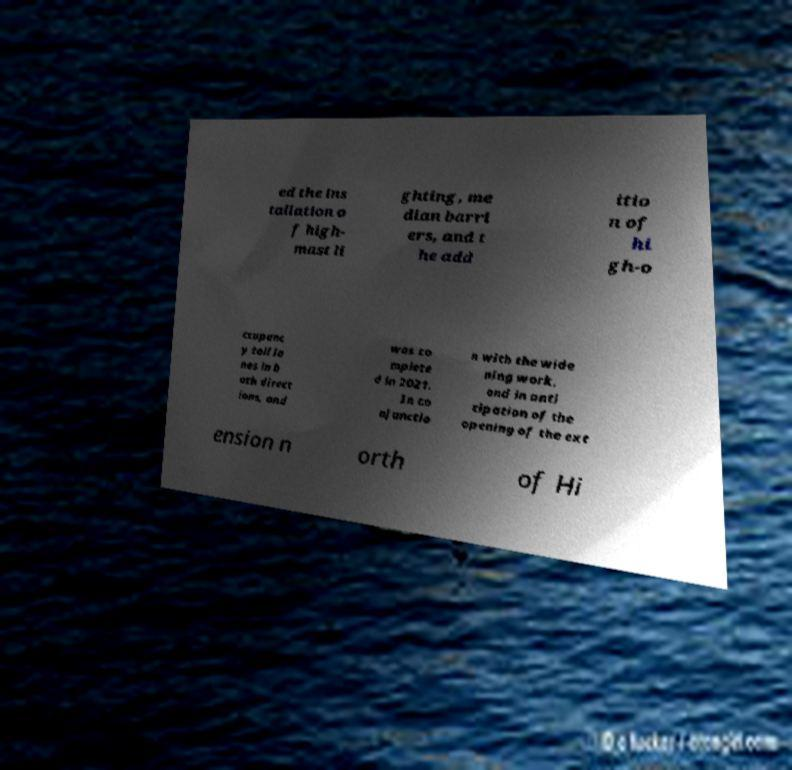I need the written content from this picture converted into text. Can you do that? ed the ins tallation o f high- mast li ghting, me dian barri ers, and t he add itio n of hi gh-o ccupanc y toll la nes in b oth direct ions, and was co mplete d in 2021. In co njunctio n with the wide ning work, and in anti cipation of the opening of the ext ension n orth of Hi 